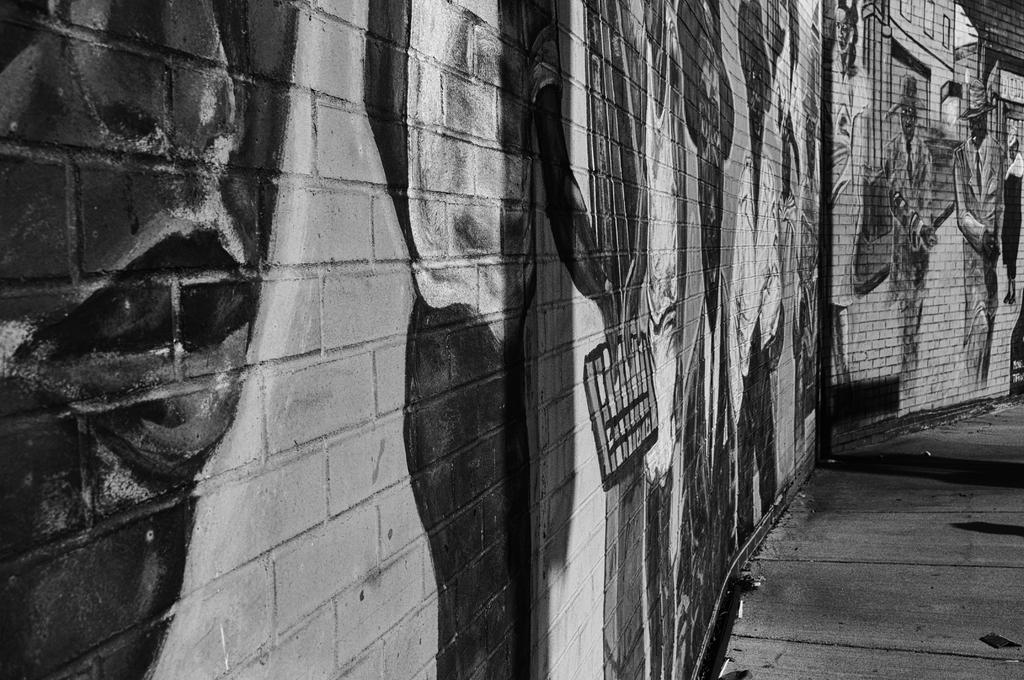What is the color scheme of the image? The image is black and white. white. What type of artwork can be seen in the image? There is graffiti in the image. What part of the image shows the pavement? The pavement is visible in the right bottom of the image. Where is the toothpaste located in the image? There is no toothpaste present in the image. What type of line can be seen connecting the graffiti to the sink in the image? There is no sink or line connecting the graffiti to a sink in the image. 